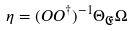<formula> <loc_0><loc_0><loc_500><loc_500>\eta = ( O O ^ { \dagger } ) ^ { - 1 } \Theta _ { \mathfrak { E } } \Omega</formula> 